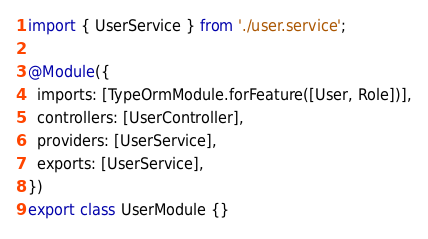Convert code to text. <code><loc_0><loc_0><loc_500><loc_500><_TypeScript_>import { UserService } from './user.service';

@Module({
  imports: [TypeOrmModule.forFeature([User, Role])],
  controllers: [UserController],
  providers: [UserService],
  exports: [UserService],
})
export class UserModule {}
</code> 